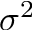<formula> <loc_0><loc_0><loc_500><loc_500>\sigma ^ { 2 }</formula> 